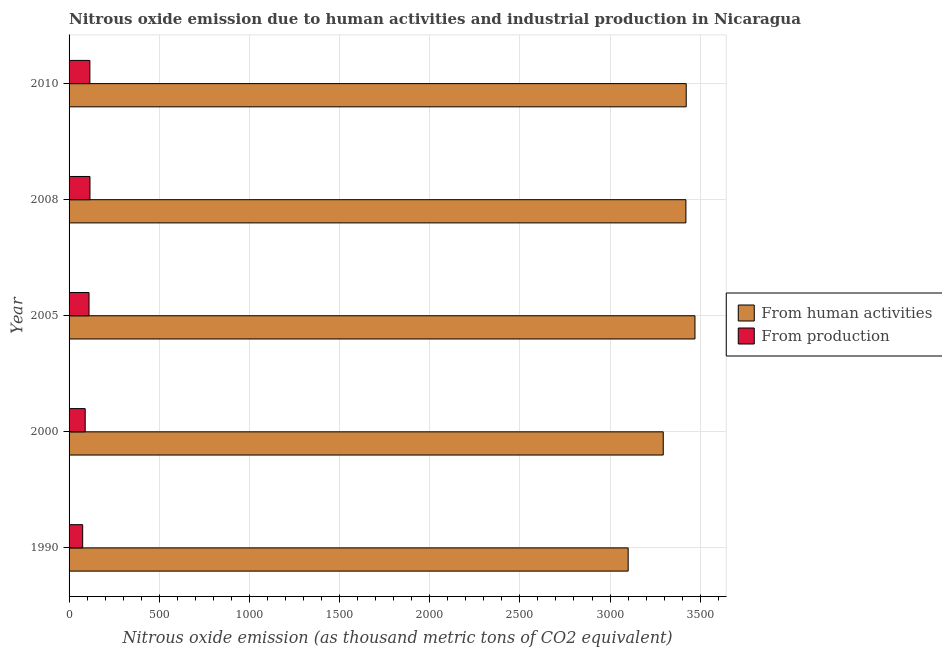How many different coloured bars are there?
Your response must be concise. 2. How many bars are there on the 1st tick from the bottom?
Ensure brevity in your answer.  2. What is the label of the 4th group of bars from the top?
Provide a short and direct response. 2000. In how many cases, is the number of bars for a given year not equal to the number of legend labels?
Your answer should be compact. 0. What is the amount of emissions from human activities in 2008?
Your answer should be very brief. 3420.8. Across all years, what is the maximum amount of emissions from human activities?
Offer a very short reply. 3471. Across all years, what is the minimum amount of emissions generated from industries?
Give a very brief answer. 75.4. In which year was the amount of emissions from human activities minimum?
Your answer should be very brief. 1990. What is the total amount of emissions generated from industries in the graph?
Make the answer very short. 506.9. What is the difference between the amount of emissions generated from industries in 2000 and that in 2010?
Keep it short and to the point. -25.9. What is the difference between the amount of emissions generated from industries in 2000 and the amount of emissions from human activities in 2008?
Your answer should be very brief. -3331.3. What is the average amount of emissions generated from industries per year?
Keep it short and to the point. 101.38. In the year 1990, what is the difference between the amount of emissions generated from industries and amount of emissions from human activities?
Offer a terse response. -3025.2. What is the ratio of the amount of emissions generated from industries in 1990 to that in 2008?
Offer a terse response. 0.65. Is the amount of emissions generated from industries in 2008 less than that in 2010?
Give a very brief answer. No. What is the difference between the highest and the second highest amount of emissions from human activities?
Your answer should be compact. 48.5. What is the difference between the highest and the lowest amount of emissions generated from industries?
Provide a succinct answer. 40.5. What does the 1st bar from the top in 1990 represents?
Your answer should be compact. From production. What does the 2nd bar from the bottom in 1990 represents?
Give a very brief answer. From production. How many years are there in the graph?
Offer a very short reply. 5. What is the difference between two consecutive major ticks on the X-axis?
Keep it short and to the point. 500. Where does the legend appear in the graph?
Ensure brevity in your answer.  Center right. What is the title of the graph?
Provide a short and direct response. Nitrous oxide emission due to human activities and industrial production in Nicaragua. Does "Current education expenditure" appear as one of the legend labels in the graph?
Offer a terse response. No. What is the label or title of the X-axis?
Your response must be concise. Nitrous oxide emission (as thousand metric tons of CO2 equivalent). What is the label or title of the Y-axis?
Make the answer very short. Year. What is the Nitrous oxide emission (as thousand metric tons of CO2 equivalent) in From human activities in 1990?
Make the answer very short. 3100.6. What is the Nitrous oxide emission (as thousand metric tons of CO2 equivalent) of From production in 1990?
Provide a succinct answer. 75.4. What is the Nitrous oxide emission (as thousand metric tons of CO2 equivalent) of From human activities in 2000?
Provide a succinct answer. 3295.1. What is the Nitrous oxide emission (as thousand metric tons of CO2 equivalent) in From production in 2000?
Keep it short and to the point. 89.5. What is the Nitrous oxide emission (as thousand metric tons of CO2 equivalent) in From human activities in 2005?
Provide a succinct answer. 3471. What is the Nitrous oxide emission (as thousand metric tons of CO2 equivalent) of From production in 2005?
Your answer should be very brief. 110.7. What is the Nitrous oxide emission (as thousand metric tons of CO2 equivalent) in From human activities in 2008?
Your response must be concise. 3420.8. What is the Nitrous oxide emission (as thousand metric tons of CO2 equivalent) of From production in 2008?
Provide a short and direct response. 115.9. What is the Nitrous oxide emission (as thousand metric tons of CO2 equivalent) of From human activities in 2010?
Your response must be concise. 3422.5. What is the Nitrous oxide emission (as thousand metric tons of CO2 equivalent) of From production in 2010?
Your response must be concise. 115.4. Across all years, what is the maximum Nitrous oxide emission (as thousand metric tons of CO2 equivalent) in From human activities?
Make the answer very short. 3471. Across all years, what is the maximum Nitrous oxide emission (as thousand metric tons of CO2 equivalent) of From production?
Provide a short and direct response. 115.9. Across all years, what is the minimum Nitrous oxide emission (as thousand metric tons of CO2 equivalent) in From human activities?
Offer a very short reply. 3100.6. Across all years, what is the minimum Nitrous oxide emission (as thousand metric tons of CO2 equivalent) of From production?
Your answer should be very brief. 75.4. What is the total Nitrous oxide emission (as thousand metric tons of CO2 equivalent) of From human activities in the graph?
Your answer should be very brief. 1.67e+04. What is the total Nitrous oxide emission (as thousand metric tons of CO2 equivalent) of From production in the graph?
Make the answer very short. 506.9. What is the difference between the Nitrous oxide emission (as thousand metric tons of CO2 equivalent) of From human activities in 1990 and that in 2000?
Provide a short and direct response. -194.5. What is the difference between the Nitrous oxide emission (as thousand metric tons of CO2 equivalent) in From production in 1990 and that in 2000?
Offer a very short reply. -14.1. What is the difference between the Nitrous oxide emission (as thousand metric tons of CO2 equivalent) of From human activities in 1990 and that in 2005?
Offer a very short reply. -370.4. What is the difference between the Nitrous oxide emission (as thousand metric tons of CO2 equivalent) in From production in 1990 and that in 2005?
Offer a terse response. -35.3. What is the difference between the Nitrous oxide emission (as thousand metric tons of CO2 equivalent) of From human activities in 1990 and that in 2008?
Give a very brief answer. -320.2. What is the difference between the Nitrous oxide emission (as thousand metric tons of CO2 equivalent) in From production in 1990 and that in 2008?
Provide a short and direct response. -40.5. What is the difference between the Nitrous oxide emission (as thousand metric tons of CO2 equivalent) of From human activities in 1990 and that in 2010?
Offer a very short reply. -321.9. What is the difference between the Nitrous oxide emission (as thousand metric tons of CO2 equivalent) of From human activities in 2000 and that in 2005?
Your response must be concise. -175.9. What is the difference between the Nitrous oxide emission (as thousand metric tons of CO2 equivalent) in From production in 2000 and that in 2005?
Keep it short and to the point. -21.2. What is the difference between the Nitrous oxide emission (as thousand metric tons of CO2 equivalent) of From human activities in 2000 and that in 2008?
Your response must be concise. -125.7. What is the difference between the Nitrous oxide emission (as thousand metric tons of CO2 equivalent) of From production in 2000 and that in 2008?
Your answer should be very brief. -26.4. What is the difference between the Nitrous oxide emission (as thousand metric tons of CO2 equivalent) of From human activities in 2000 and that in 2010?
Offer a very short reply. -127.4. What is the difference between the Nitrous oxide emission (as thousand metric tons of CO2 equivalent) of From production in 2000 and that in 2010?
Your answer should be very brief. -25.9. What is the difference between the Nitrous oxide emission (as thousand metric tons of CO2 equivalent) of From human activities in 2005 and that in 2008?
Your answer should be very brief. 50.2. What is the difference between the Nitrous oxide emission (as thousand metric tons of CO2 equivalent) in From human activities in 2005 and that in 2010?
Provide a succinct answer. 48.5. What is the difference between the Nitrous oxide emission (as thousand metric tons of CO2 equivalent) in From production in 2005 and that in 2010?
Provide a succinct answer. -4.7. What is the difference between the Nitrous oxide emission (as thousand metric tons of CO2 equivalent) of From human activities in 1990 and the Nitrous oxide emission (as thousand metric tons of CO2 equivalent) of From production in 2000?
Provide a succinct answer. 3011.1. What is the difference between the Nitrous oxide emission (as thousand metric tons of CO2 equivalent) of From human activities in 1990 and the Nitrous oxide emission (as thousand metric tons of CO2 equivalent) of From production in 2005?
Make the answer very short. 2989.9. What is the difference between the Nitrous oxide emission (as thousand metric tons of CO2 equivalent) of From human activities in 1990 and the Nitrous oxide emission (as thousand metric tons of CO2 equivalent) of From production in 2008?
Make the answer very short. 2984.7. What is the difference between the Nitrous oxide emission (as thousand metric tons of CO2 equivalent) in From human activities in 1990 and the Nitrous oxide emission (as thousand metric tons of CO2 equivalent) in From production in 2010?
Your response must be concise. 2985.2. What is the difference between the Nitrous oxide emission (as thousand metric tons of CO2 equivalent) of From human activities in 2000 and the Nitrous oxide emission (as thousand metric tons of CO2 equivalent) of From production in 2005?
Provide a succinct answer. 3184.4. What is the difference between the Nitrous oxide emission (as thousand metric tons of CO2 equivalent) of From human activities in 2000 and the Nitrous oxide emission (as thousand metric tons of CO2 equivalent) of From production in 2008?
Your answer should be compact. 3179.2. What is the difference between the Nitrous oxide emission (as thousand metric tons of CO2 equivalent) of From human activities in 2000 and the Nitrous oxide emission (as thousand metric tons of CO2 equivalent) of From production in 2010?
Offer a terse response. 3179.7. What is the difference between the Nitrous oxide emission (as thousand metric tons of CO2 equivalent) in From human activities in 2005 and the Nitrous oxide emission (as thousand metric tons of CO2 equivalent) in From production in 2008?
Your answer should be very brief. 3355.1. What is the difference between the Nitrous oxide emission (as thousand metric tons of CO2 equivalent) of From human activities in 2005 and the Nitrous oxide emission (as thousand metric tons of CO2 equivalent) of From production in 2010?
Your answer should be very brief. 3355.6. What is the difference between the Nitrous oxide emission (as thousand metric tons of CO2 equivalent) in From human activities in 2008 and the Nitrous oxide emission (as thousand metric tons of CO2 equivalent) in From production in 2010?
Offer a very short reply. 3305.4. What is the average Nitrous oxide emission (as thousand metric tons of CO2 equivalent) of From human activities per year?
Give a very brief answer. 3342. What is the average Nitrous oxide emission (as thousand metric tons of CO2 equivalent) of From production per year?
Your answer should be very brief. 101.38. In the year 1990, what is the difference between the Nitrous oxide emission (as thousand metric tons of CO2 equivalent) of From human activities and Nitrous oxide emission (as thousand metric tons of CO2 equivalent) of From production?
Your response must be concise. 3025.2. In the year 2000, what is the difference between the Nitrous oxide emission (as thousand metric tons of CO2 equivalent) in From human activities and Nitrous oxide emission (as thousand metric tons of CO2 equivalent) in From production?
Ensure brevity in your answer.  3205.6. In the year 2005, what is the difference between the Nitrous oxide emission (as thousand metric tons of CO2 equivalent) in From human activities and Nitrous oxide emission (as thousand metric tons of CO2 equivalent) in From production?
Your response must be concise. 3360.3. In the year 2008, what is the difference between the Nitrous oxide emission (as thousand metric tons of CO2 equivalent) in From human activities and Nitrous oxide emission (as thousand metric tons of CO2 equivalent) in From production?
Your response must be concise. 3304.9. In the year 2010, what is the difference between the Nitrous oxide emission (as thousand metric tons of CO2 equivalent) in From human activities and Nitrous oxide emission (as thousand metric tons of CO2 equivalent) in From production?
Your answer should be compact. 3307.1. What is the ratio of the Nitrous oxide emission (as thousand metric tons of CO2 equivalent) in From human activities in 1990 to that in 2000?
Keep it short and to the point. 0.94. What is the ratio of the Nitrous oxide emission (as thousand metric tons of CO2 equivalent) in From production in 1990 to that in 2000?
Offer a terse response. 0.84. What is the ratio of the Nitrous oxide emission (as thousand metric tons of CO2 equivalent) in From human activities in 1990 to that in 2005?
Your answer should be very brief. 0.89. What is the ratio of the Nitrous oxide emission (as thousand metric tons of CO2 equivalent) of From production in 1990 to that in 2005?
Provide a succinct answer. 0.68. What is the ratio of the Nitrous oxide emission (as thousand metric tons of CO2 equivalent) in From human activities in 1990 to that in 2008?
Provide a short and direct response. 0.91. What is the ratio of the Nitrous oxide emission (as thousand metric tons of CO2 equivalent) in From production in 1990 to that in 2008?
Keep it short and to the point. 0.65. What is the ratio of the Nitrous oxide emission (as thousand metric tons of CO2 equivalent) of From human activities in 1990 to that in 2010?
Give a very brief answer. 0.91. What is the ratio of the Nitrous oxide emission (as thousand metric tons of CO2 equivalent) of From production in 1990 to that in 2010?
Offer a terse response. 0.65. What is the ratio of the Nitrous oxide emission (as thousand metric tons of CO2 equivalent) in From human activities in 2000 to that in 2005?
Keep it short and to the point. 0.95. What is the ratio of the Nitrous oxide emission (as thousand metric tons of CO2 equivalent) in From production in 2000 to that in 2005?
Provide a short and direct response. 0.81. What is the ratio of the Nitrous oxide emission (as thousand metric tons of CO2 equivalent) of From human activities in 2000 to that in 2008?
Offer a terse response. 0.96. What is the ratio of the Nitrous oxide emission (as thousand metric tons of CO2 equivalent) of From production in 2000 to that in 2008?
Your answer should be very brief. 0.77. What is the ratio of the Nitrous oxide emission (as thousand metric tons of CO2 equivalent) of From human activities in 2000 to that in 2010?
Give a very brief answer. 0.96. What is the ratio of the Nitrous oxide emission (as thousand metric tons of CO2 equivalent) of From production in 2000 to that in 2010?
Provide a succinct answer. 0.78. What is the ratio of the Nitrous oxide emission (as thousand metric tons of CO2 equivalent) in From human activities in 2005 to that in 2008?
Provide a short and direct response. 1.01. What is the ratio of the Nitrous oxide emission (as thousand metric tons of CO2 equivalent) of From production in 2005 to that in 2008?
Provide a short and direct response. 0.96. What is the ratio of the Nitrous oxide emission (as thousand metric tons of CO2 equivalent) of From human activities in 2005 to that in 2010?
Provide a short and direct response. 1.01. What is the ratio of the Nitrous oxide emission (as thousand metric tons of CO2 equivalent) in From production in 2005 to that in 2010?
Offer a very short reply. 0.96. What is the difference between the highest and the second highest Nitrous oxide emission (as thousand metric tons of CO2 equivalent) in From human activities?
Keep it short and to the point. 48.5. What is the difference between the highest and the lowest Nitrous oxide emission (as thousand metric tons of CO2 equivalent) in From human activities?
Offer a terse response. 370.4. What is the difference between the highest and the lowest Nitrous oxide emission (as thousand metric tons of CO2 equivalent) in From production?
Give a very brief answer. 40.5. 